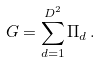<formula> <loc_0><loc_0><loc_500><loc_500>G = \sum _ { d = 1 } ^ { D ^ { 2 } } \Pi _ { d } \, .</formula> 